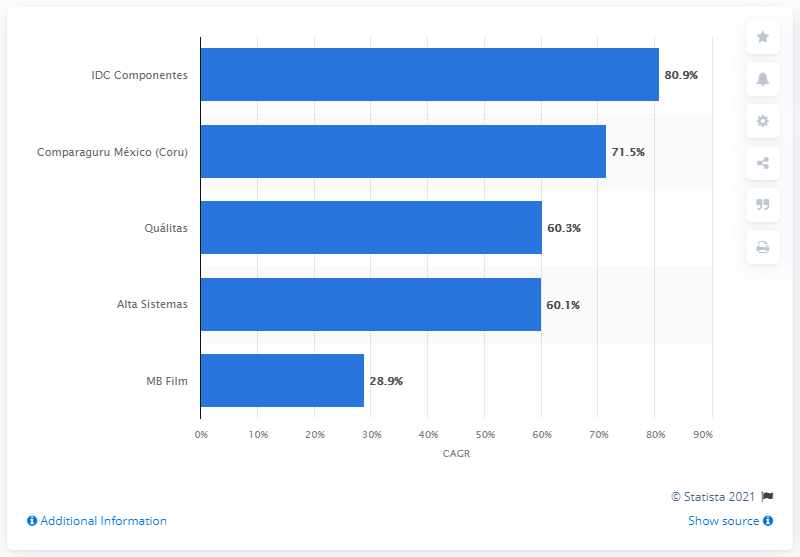Specify some key components in this picture. Mexico's fastest-growing company between 2016 and 2019 was IDC Componentes, according to a report by IDC. Between 2016 and 2019, IDC Componentes experienced a compound annual growth rate of 80.9%. The Compounded Annual Growth Rate (CAGR) of Coru between 2016 and 2019 was 71.5%. 